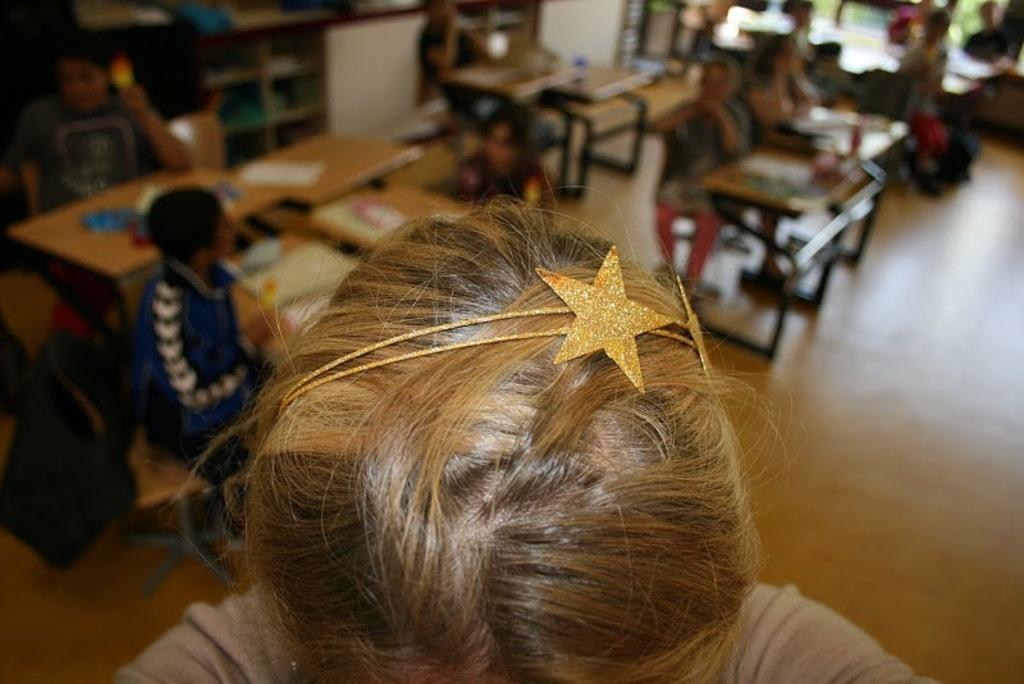How would you summarize this image in a sentence or two? In this picture we can see a person with a hair accessory. Behind the person, there are groups of people sitting on benches. Behind the people there are tables and some blurred objects. 